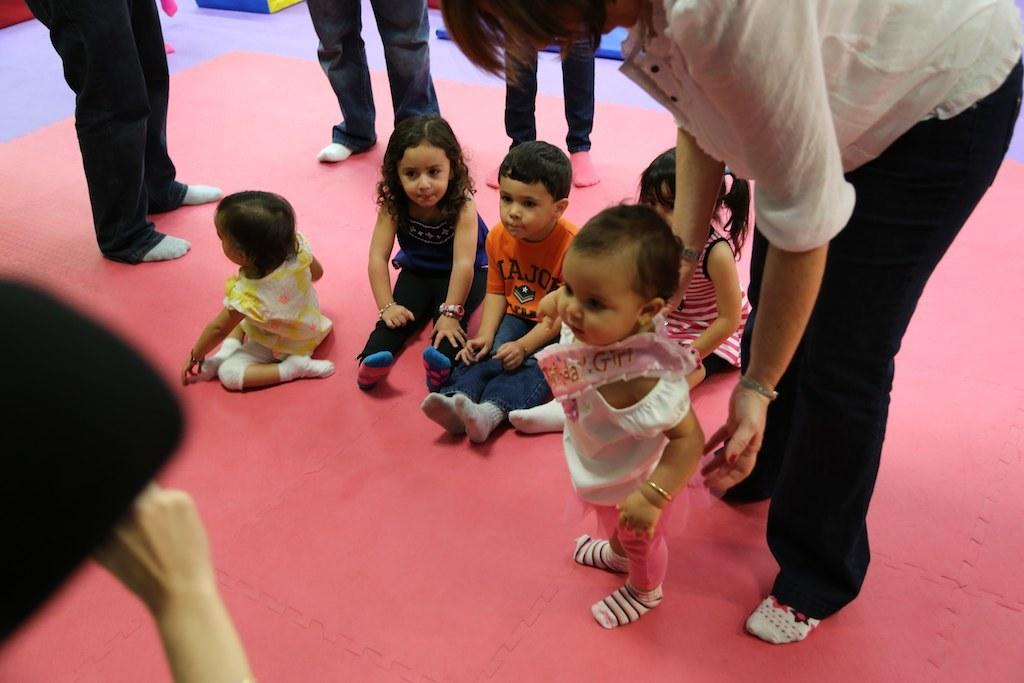How many people are in the image? There are a few people in the image. What can be seen beneath the people in the image? The ground is visible in the image. What is present on the ground in the image? There are objects on the ground. Where is an object located in the image? There is an object on the left side of the image. What is the name of the person who is walking in the image? There is no person walking in the image, so it is not possible to determine their name. 